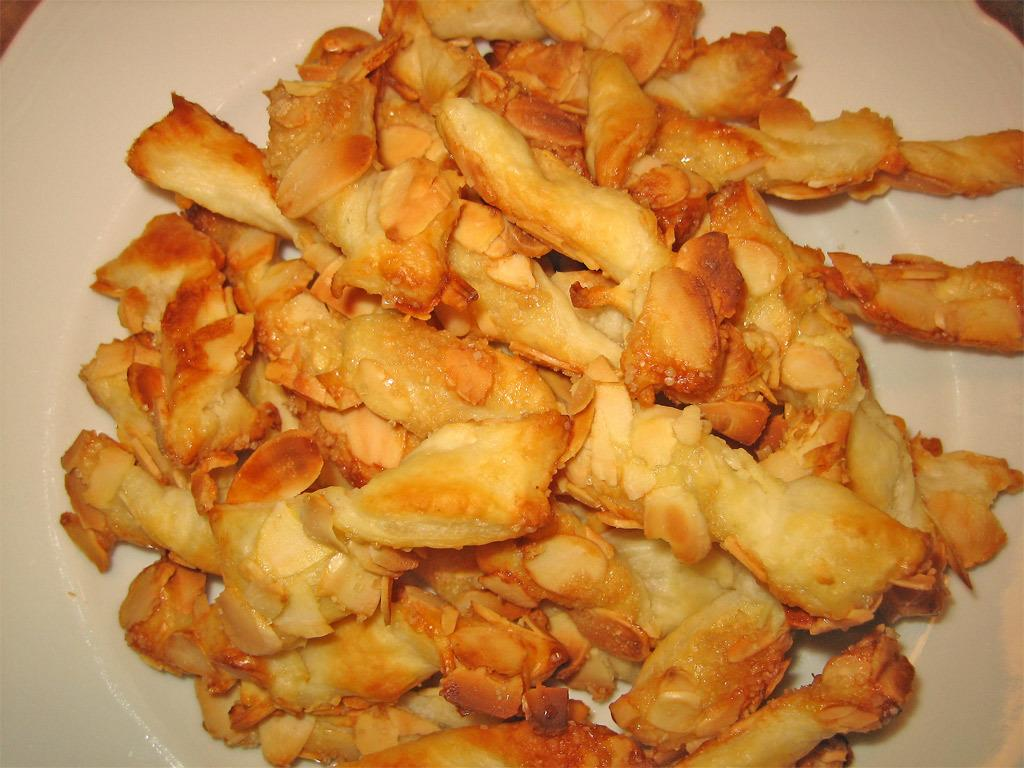What is the main subject of the image? The main subject of the image is food. Where is the food located in the image? The food is in the center of the image. What type of dish is the food placed on? There is a white plate in the image. How does the girl measure the liquid in the bottle in the image? There is no girl or bottle present in the image, so this question cannot be answered. 